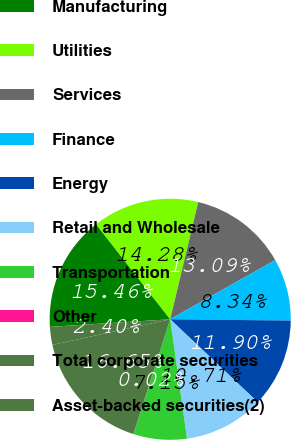Convert chart. <chart><loc_0><loc_0><loc_500><loc_500><pie_chart><fcel>Manufacturing<fcel>Utilities<fcel>Services<fcel>Finance<fcel>Energy<fcel>Retail and Wholesale<fcel>Transportation<fcel>Other<fcel>Total corporate securities<fcel>Asset-backed securities(2)<nl><fcel>15.46%<fcel>14.28%<fcel>13.09%<fcel>8.34%<fcel>11.9%<fcel>10.71%<fcel>7.15%<fcel>0.02%<fcel>16.65%<fcel>2.4%<nl></chart> 